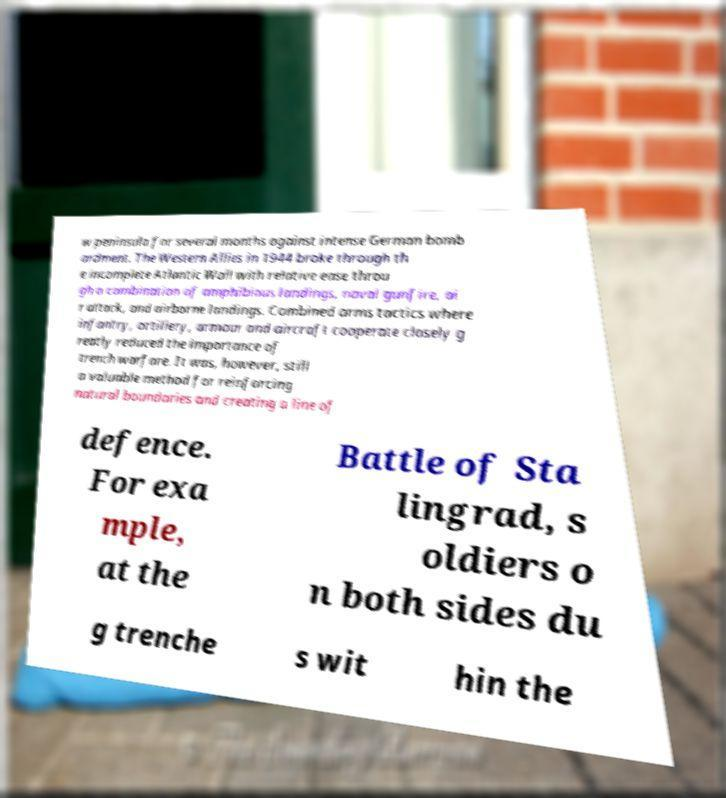Can you read and provide the text displayed in the image?This photo seems to have some interesting text. Can you extract and type it out for me? w peninsula for several months against intense German bomb ardment. The Western Allies in 1944 broke through th e incomplete Atlantic Wall with relative ease throu gh a combination of amphibious landings, naval gunfire, ai r attack, and airborne landings. Combined arms tactics where infantry, artillery, armour and aircraft cooperate closely g reatly reduced the importance of trench warfare. It was, however, still a valuable method for reinforcing natural boundaries and creating a line of defence. For exa mple, at the Battle of Sta lingrad, s oldiers o n both sides du g trenche s wit hin the 